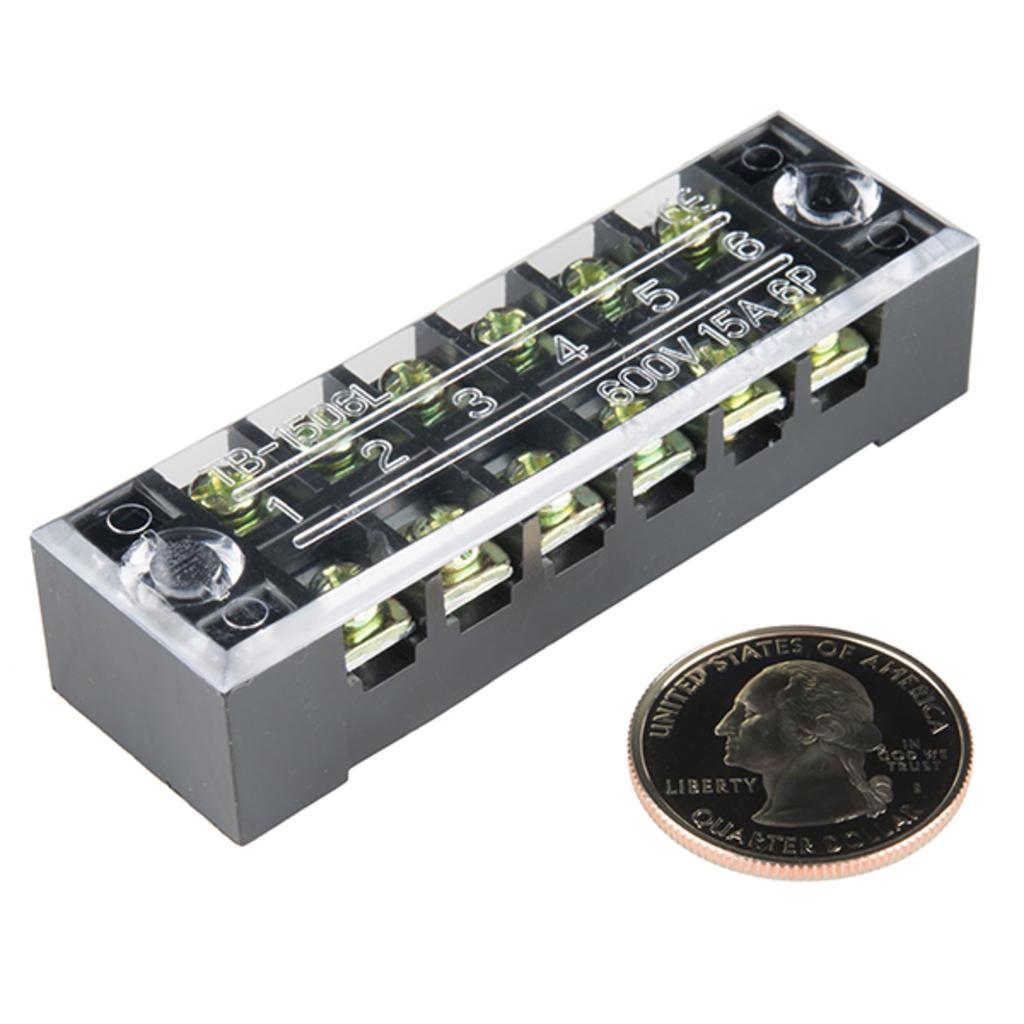Can you describe this image briefly? In this image we can see 6 way terminal block and a coin. In the background the image is white in color. 